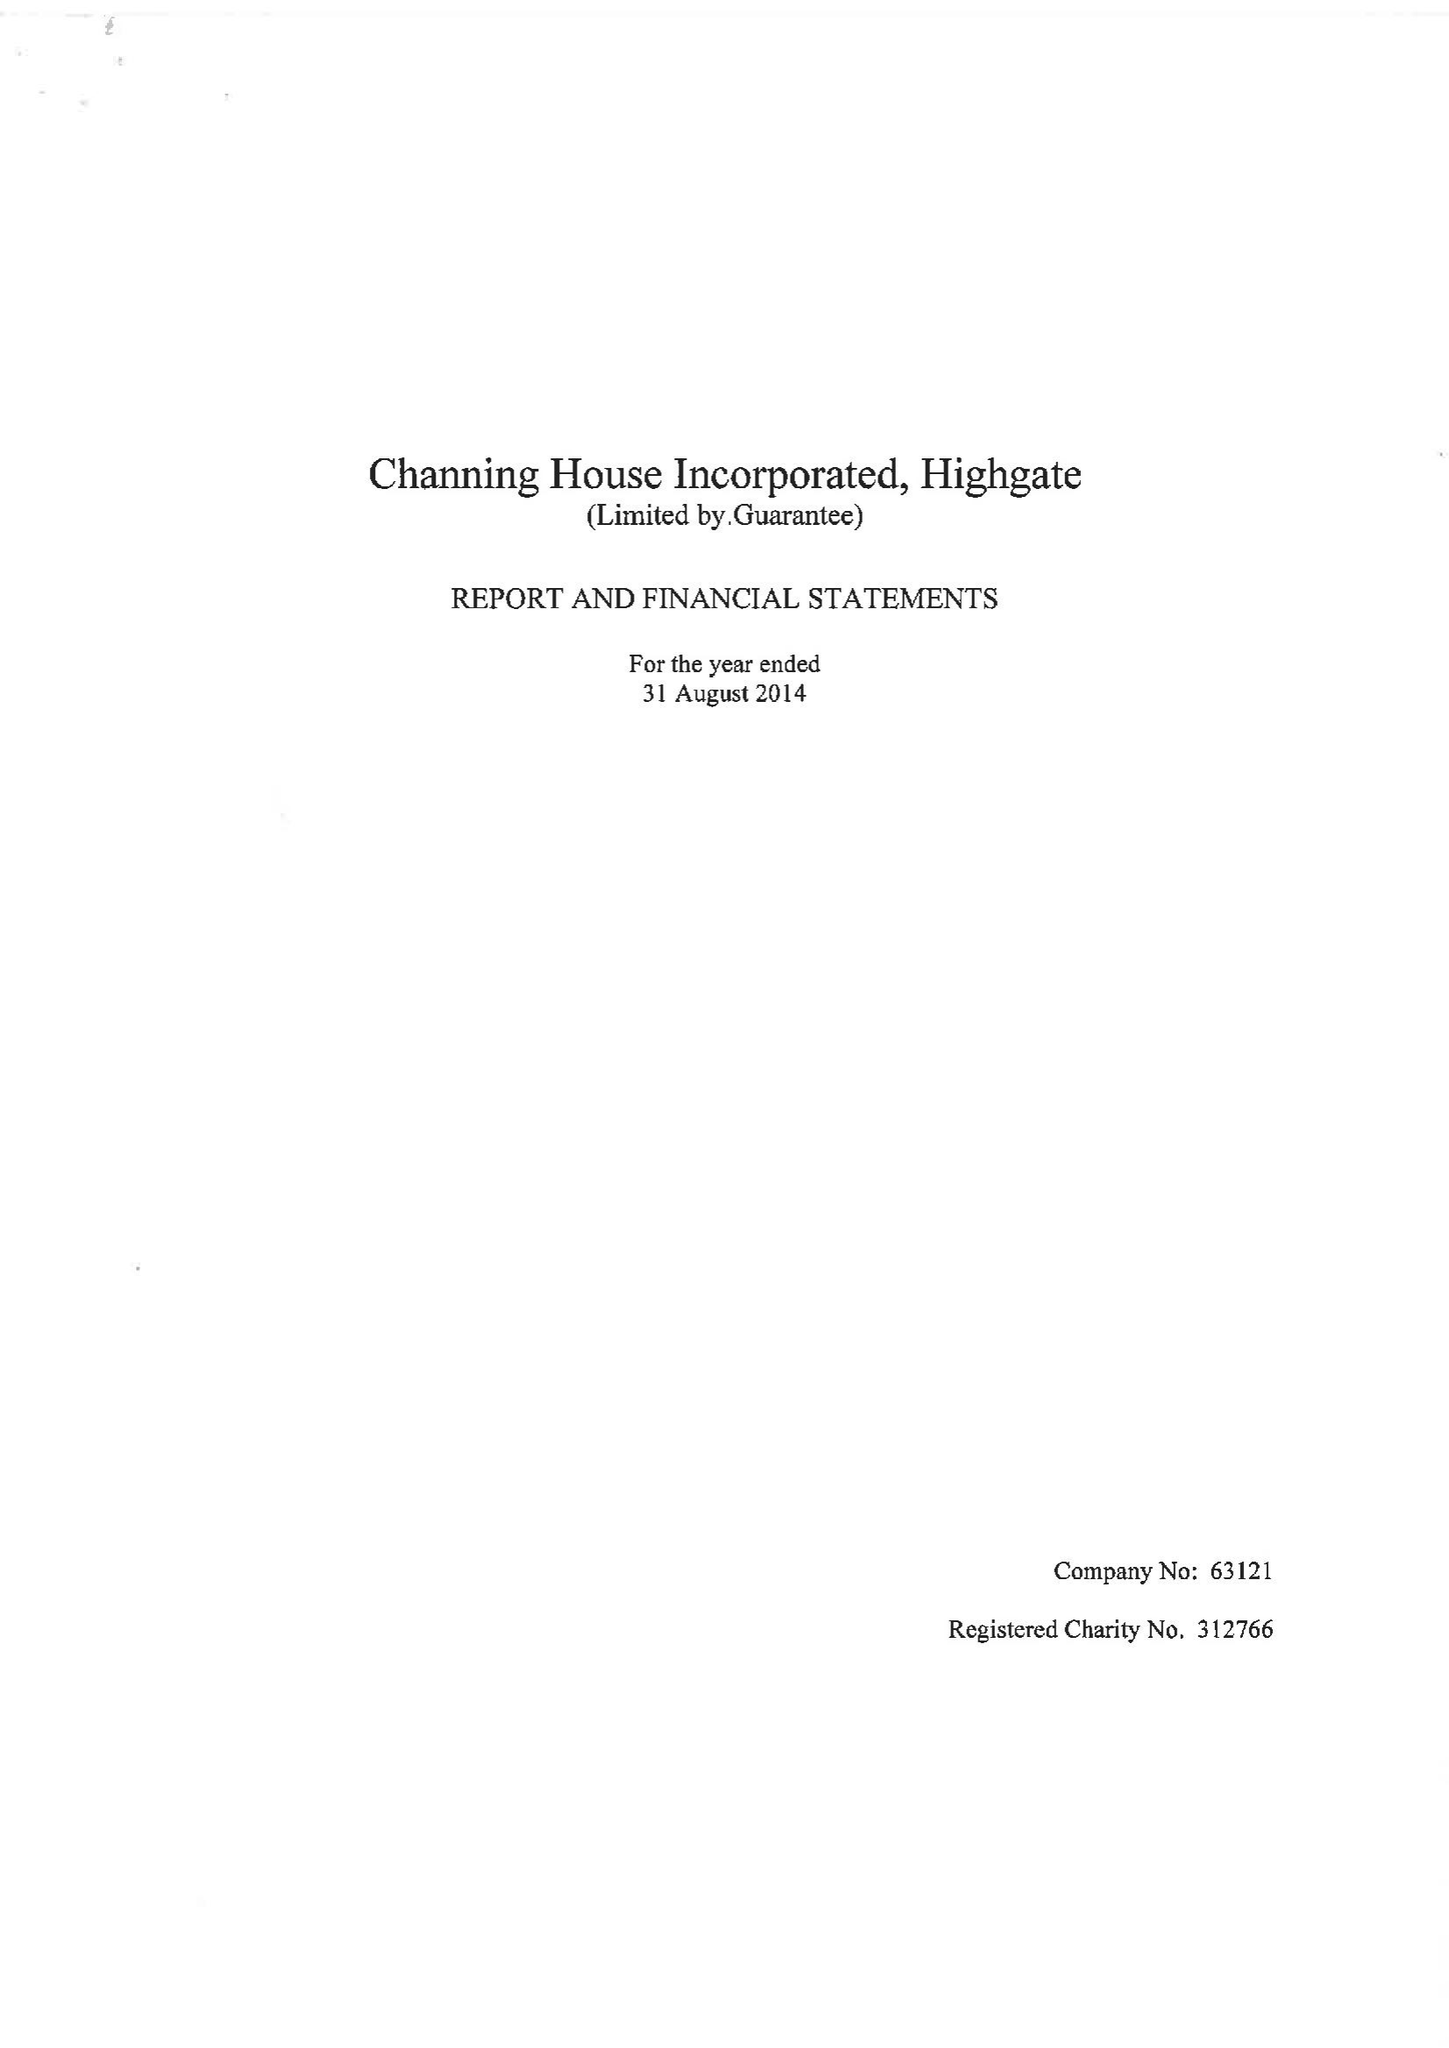What is the value for the income_annually_in_british_pounds?
Answer the question using a single word or phrase. 10570966.00 